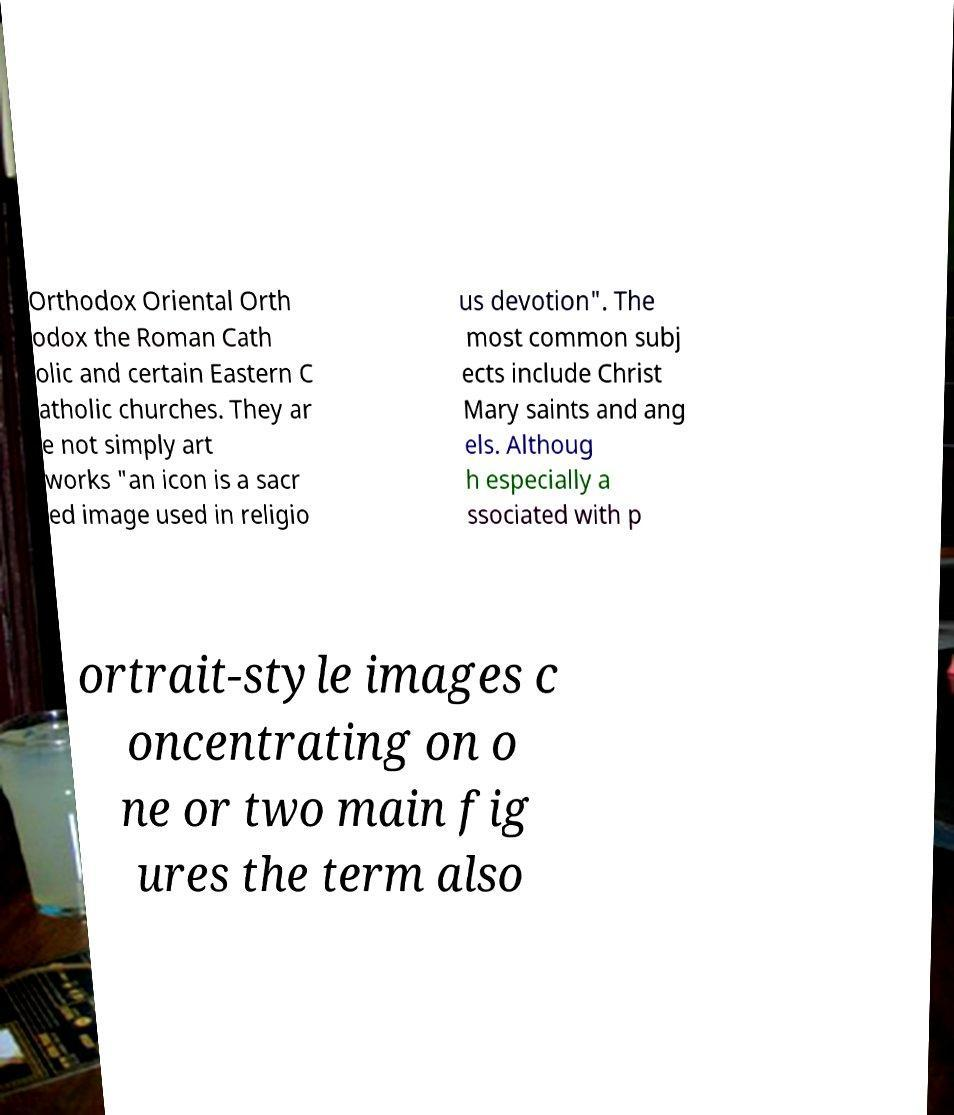Can you accurately transcribe the text from the provided image for me? Orthodox Oriental Orth odox the Roman Cath olic and certain Eastern C atholic churches. They ar e not simply art works "an icon is a sacr ed image used in religio us devotion". The most common subj ects include Christ Mary saints and ang els. Althoug h especially a ssociated with p ortrait-style images c oncentrating on o ne or two main fig ures the term also 